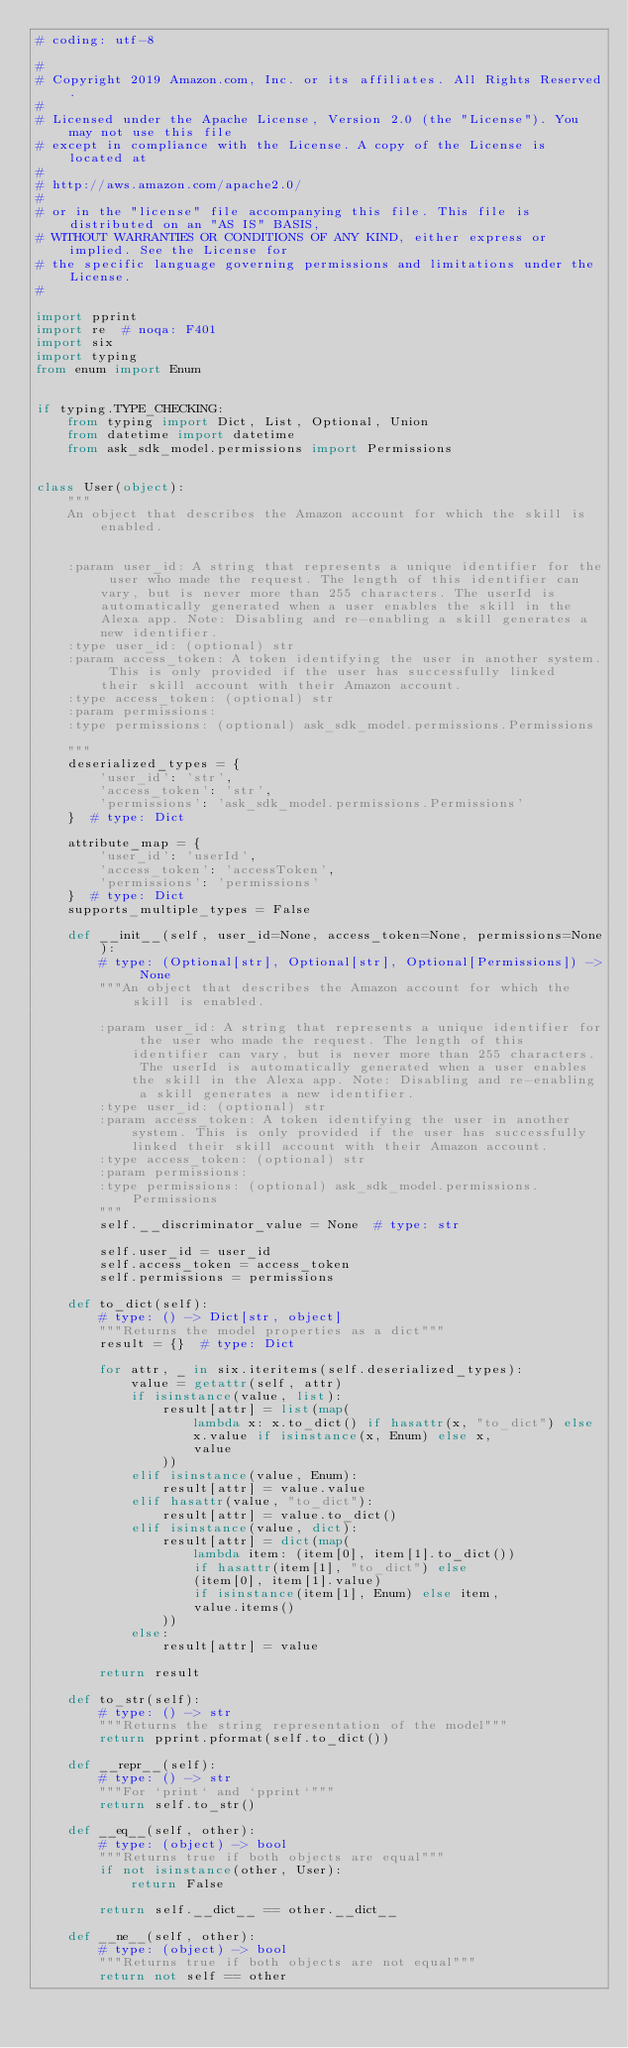Convert code to text. <code><loc_0><loc_0><loc_500><loc_500><_Python_># coding: utf-8

#
# Copyright 2019 Amazon.com, Inc. or its affiliates. All Rights Reserved.
#
# Licensed under the Apache License, Version 2.0 (the "License"). You may not use this file
# except in compliance with the License. A copy of the License is located at
#
# http://aws.amazon.com/apache2.0/
#
# or in the "license" file accompanying this file. This file is distributed on an "AS IS" BASIS,
# WITHOUT WARRANTIES OR CONDITIONS OF ANY KIND, either express or implied. See the License for
# the specific language governing permissions and limitations under the License.
#

import pprint
import re  # noqa: F401
import six
import typing
from enum import Enum


if typing.TYPE_CHECKING:
    from typing import Dict, List, Optional, Union
    from datetime import datetime
    from ask_sdk_model.permissions import Permissions


class User(object):
    """
    An object that describes the Amazon account for which the skill is enabled.


    :param user_id: A string that represents a unique identifier for the user who made the request. The length of this identifier can vary, but is never more than 255 characters. The userId is automatically generated when a user enables the skill in the Alexa app. Note: Disabling and re-enabling a skill generates a new identifier.
    :type user_id: (optional) str
    :param access_token: A token identifying the user in another system. This is only provided if the user has successfully linked their skill account with their Amazon account.
    :type access_token: (optional) str
    :param permissions: 
    :type permissions: (optional) ask_sdk_model.permissions.Permissions

    """
    deserialized_types = {
        'user_id': 'str',
        'access_token': 'str',
        'permissions': 'ask_sdk_model.permissions.Permissions'
    }  # type: Dict

    attribute_map = {
        'user_id': 'userId',
        'access_token': 'accessToken',
        'permissions': 'permissions'
    }  # type: Dict
    supports_multiple_types = False

    def __init__(self, user_id=None, access_token=None, permissions=None):
        # type: (Optional[str], Optional[str], Optional[Permissions]) -> None
        """An object that describes the Amazon account for which the skill is enabled.

        :param user_id: A string that represents a unique identifier for the user who made the request. The length of this identifier can vary, but is never more than 255 characters. The userId is automatically generated when a user enables the skill in the Alexa app. Note: Disabling and re-enabling a skill generates a new identifier.
        :type user_id: (optional) str
        :param access_token: A token identifying the user in another system. This is only provided if the user has successfully linked their skill account with their Amazon account.
        :type access_token: (optional) str
        :param permissions: 
        :type permissions: (optional) ask_sdk_model.permissions.Permissions
        """
        self.__discriminator_value = None  # type: str

        self.user_id = user_id
        self.access_token = access_token
        self.permissions = permissions

    def to_dict(self):
        # type: () -> Dict[str, object]
        """Returns the model properties as a dict"""
        result = {}  # type: Dict

        for attr, _ in six.iteritems(self.deserialized_types):
            value = getattr(self, attr)
            if isinstance(value, list):
                result[attr] = list(map(
                    lambda x: x.to_dict() if hasattr(x, "to_dict") else
                    x.value if isinstance(x, Enum) else x,
                    value
                ))
            elif isinstance(value, Enum):
                result[attr] = value.value
            elif hasattr(value, "to_dict"):
                result[attr] = value.to_dict()
            elif isinstance(value, dict):
                result[attr] = dict(map(
                    lambda item: (item[0], item[1].to_dict())
                    if hasattr(item[1], "to_dict") else
                    (item[0], item[1].value)
                    if isinstance(item[1], Enum) else item,
                    value.items()
                ))
            else:
                result[attr] = value

        return result

    def to_str(self):
        # type: () -> str
        """Returns the string representation of the model"""
        return pprint.pformat(self.to_dict())

    def __repr__(self):
        # type: () -> str
        """For `print` and `pprint`"""
        return self.to_str()

    def __eq__(self, other):
        # type: (object) -> bool
        """Returns true if both objects are equal"""
        if not isinstance(other, User):
            return False

        return self.__dict__ == other.__dict__

    def __ne__(self, other):
        # type: (object) -> bool
        """Returns true if both objects are not equal"""
        return not self == other
</code> 